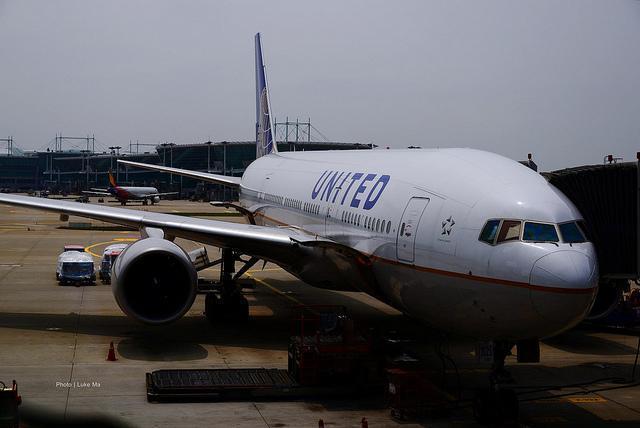How many people can be seen in the picture?
Give a very brief answer. 0. How many frisbees are in the basket?
Give a very brief answer. 0. 